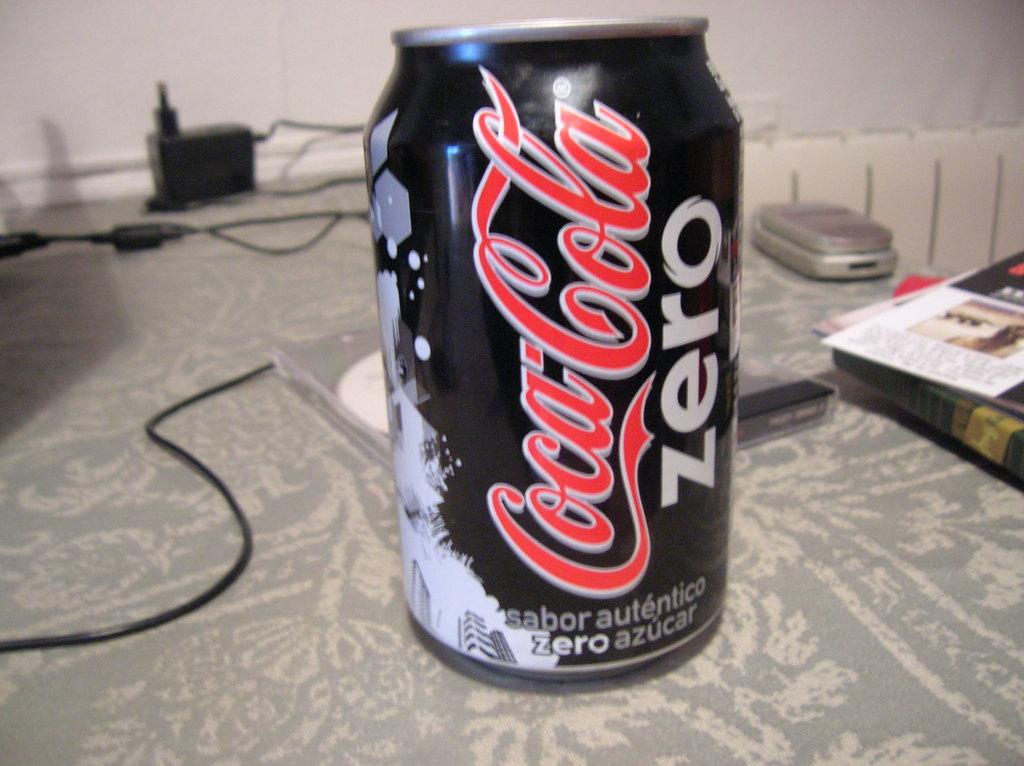Provide a one-sentence caption for the provided image. A can of Coca-cola zero on a patterned gray tablecloth. 